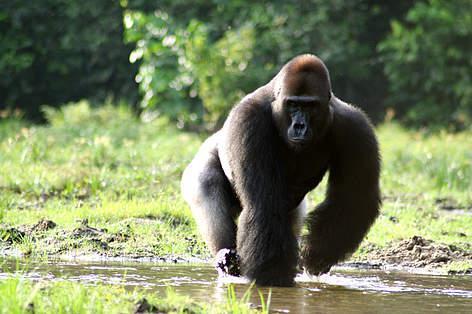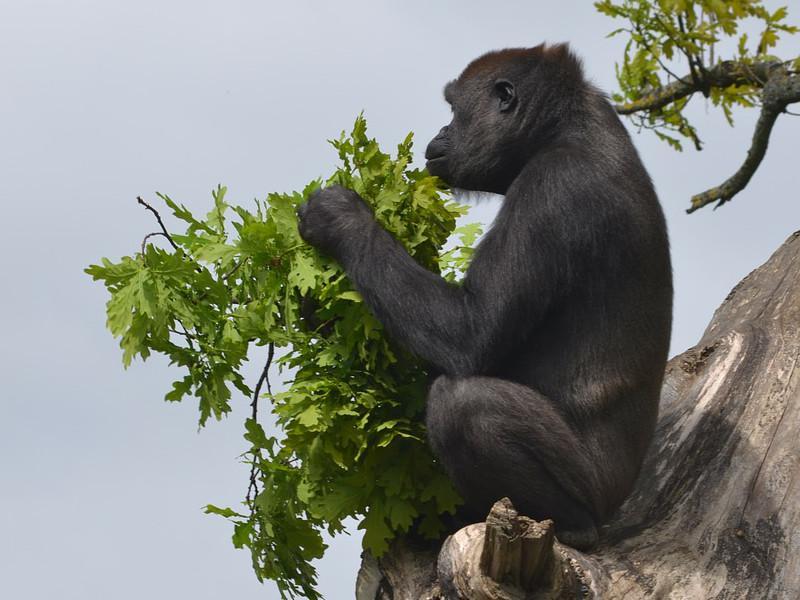The first image is the image on the left, the second image is the image on the right. Evaluate the accuracy of this statement regarding the images: "The left image shows a lone gorilla munching foliage, and the right image shows at least one adult gorilla with a baby gorilla.". Is it true? Answer yes or no. No. The first image is the image on the left, the second image is the image on the right. Analyze the images presented: Is the assertion "There are at least two gorillas in the right image." valid? Answer yes or no. No. 